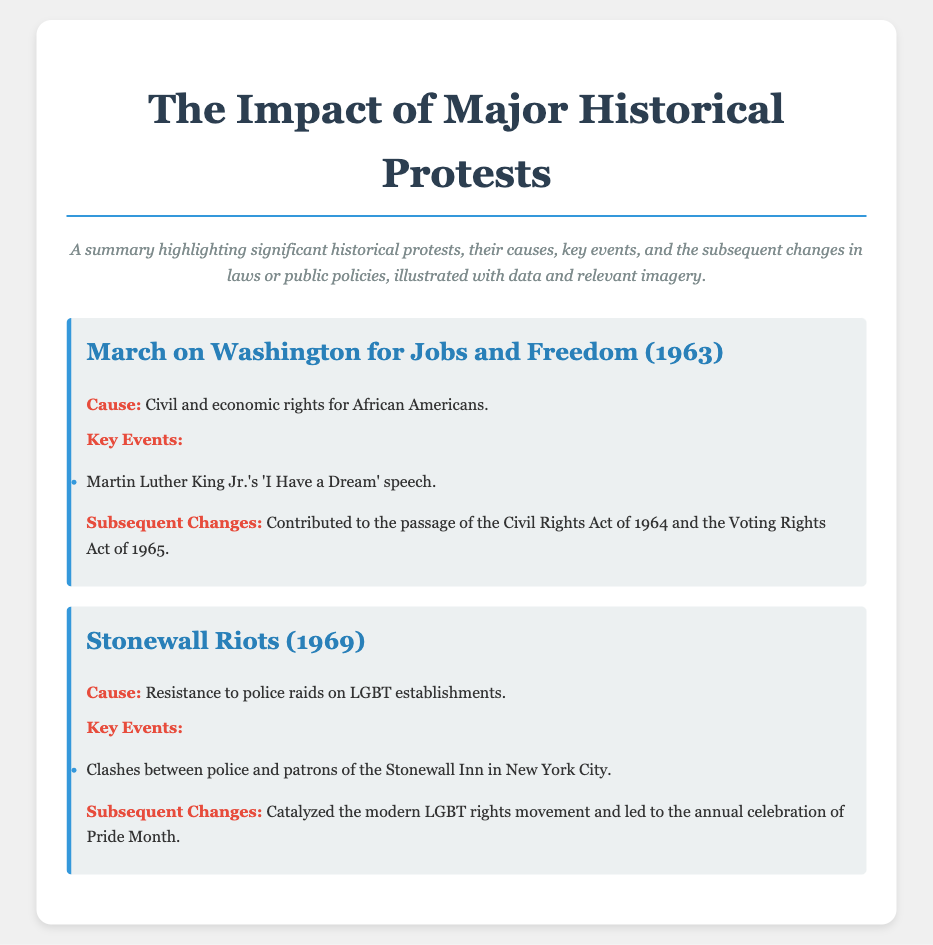What was the year of the March on Washington? The document states that the March on Washington for Jobs and Freedom occurred in 1963.
Answer: 1963 What was the main cause of the Stonewall Riots? According to the document, the main cause of the Stonewall Riots was resistance to police raids on LGBT establishments.
Answer: Resistance to police raids on LGBT establishments Who delivered the 'I Have a Dream' speech? The document mentions that Martin Luther King Jr. delivered the famous speech during the March on Washington.
Answer: Martin Luther King Jr What significant laws were influenced by the March on Washington? The document highlights that the Civil Rights Act of 1964 and the Voting Rights Act of 1965 were influenced by the March on Washington.
Answer: Civil Rights Act of 1964 and Voting Rights Act of 1965 What event is celebrated annually as a result of the Stonewall Riots? The document notes that the Stonewall Riots catalyzed the celebration of Pride Month annually.
Answer: Pride Month How many key events are listed for the Stonewall Riots? The document lists one key event for the Stonewall Riots, which is the clashes between police and patrons.
Answer: One What is the primary focus of this recipe card? The document's introduction states that it focuses on the impact of major historical protests.
Answer: Impact of major historical protests 